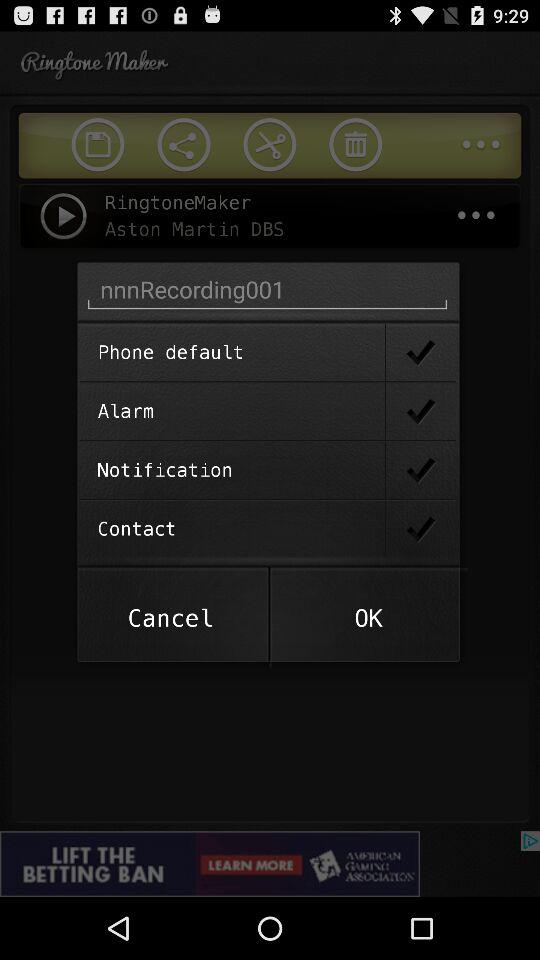What is the name of the singer whose song is played in ringtone maker?
When the provided information is insufficient, respond with <no answer>. <no answer> 